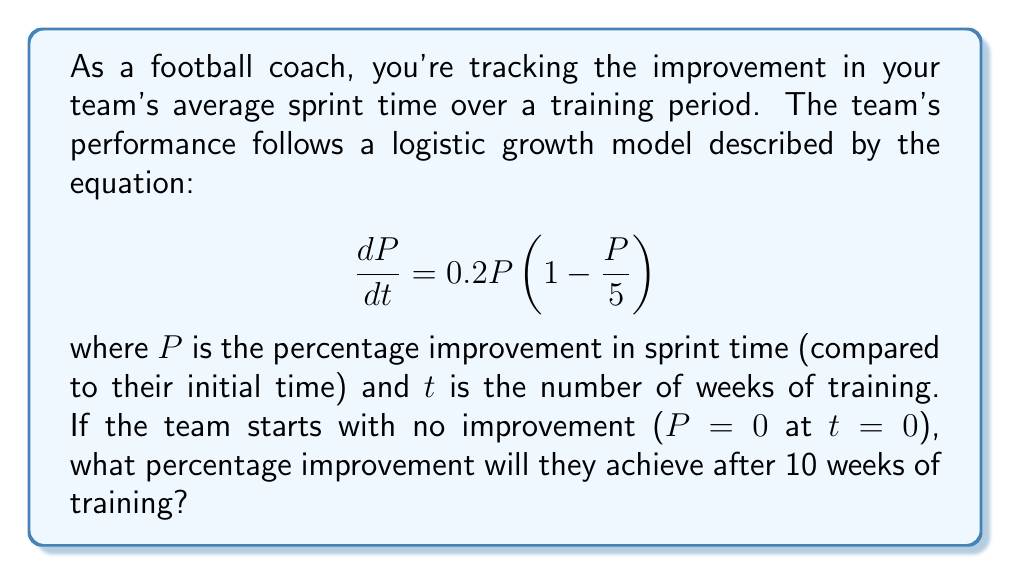Can you answer this question? To solve this problem, we need to use the logistic growth equation and its solution. The general form of the logistic equation is:

$$\frac{dP}{dt} = rP(1 - \frac{P}{K})$$

where $r$ is the growth rate and $K$ is the carrying capacity.

In our case, $r = 0.2$ and $K = 5$ (or 5%).

The solution to the logistic equation is:

$$P(t) = \frac{K}{1 + (\frac{K}{P_0} - 1)e^{-rt}}$$

where $P_0$ is the initial value of $P$.

Given:
- $K = 5$
- $r = 0.2$
- $P_0 = 0$
- $t = 10$

Since $P_0 = 0$, we need to use a small positive value instead to avoid division by zero. Let's use $P_0 = 0.01$.

Plugging in the values:

$$P(10) = \frac{5}{1 + (\frac{5}{0.01} - 1)e^{-0.2(10)}}$$

$$= \frac{5}{1 + (500 - 1)e^{-2}}$$

$$= \frac{5}{1 + 499e^{-2}}$$

$$= \frac{5}{1 + 499 \cdot 0.1353}$$

$$= \frac{5}{68.5147}$$

$$= 0.0730 \text{ or } 7.30\%$$

Therefore, after 10 weeks of training, the team will achieve approximately a 7.30% improvement in their sprint time.
Answer: 7.30% 